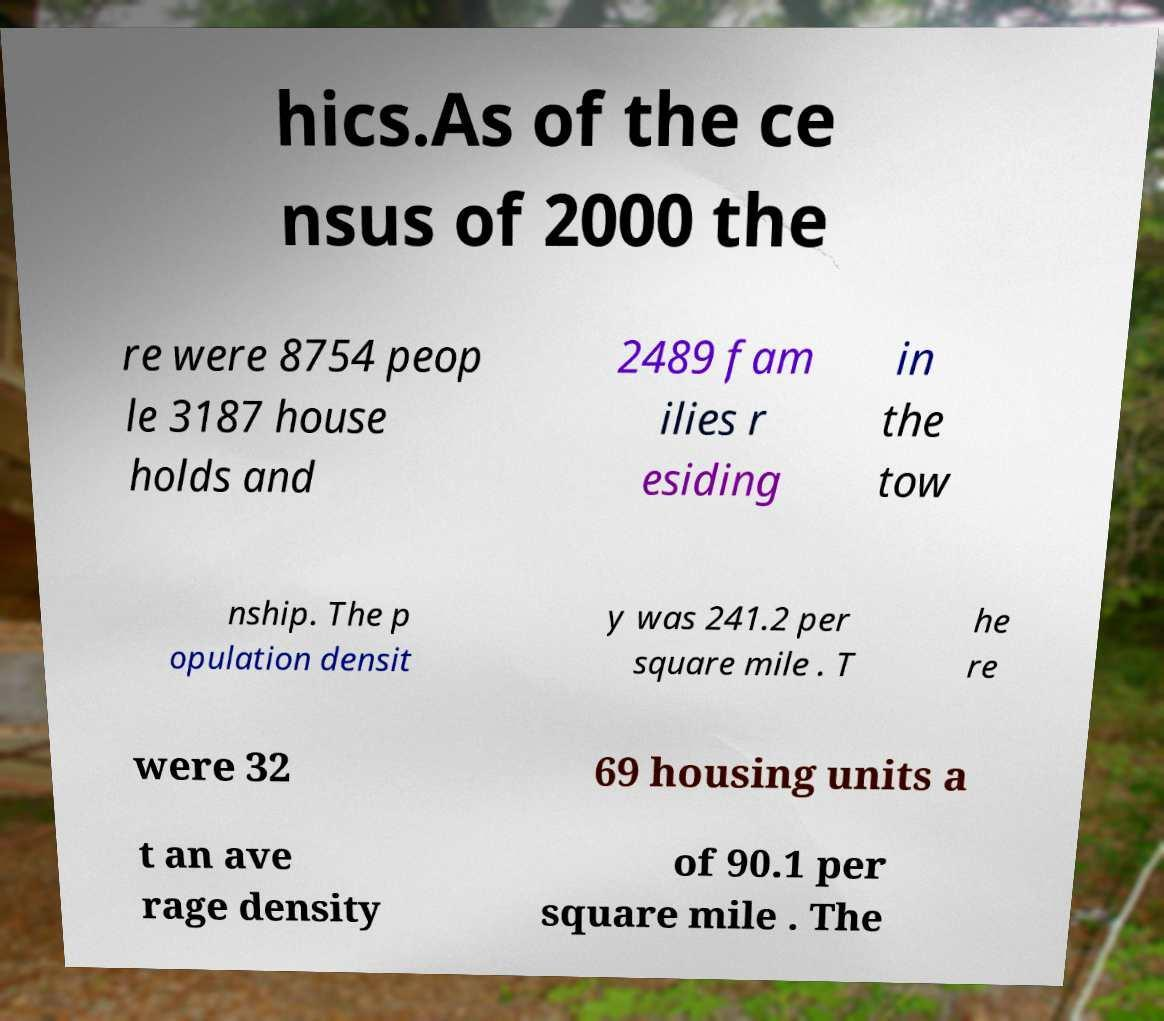There's text embedded in this image that I need extracted. Can you transcribe it verbatim? hics.As of the ce nsus of 2000 the re were 8754 peop le 3187 house holds and 2489 fam ilies r esiding in the tow nship. The p opulation densit y was 241.2 per square mile . T he re were 32 69 housing units a t an ave rage density of 90.1 per square mile . The 